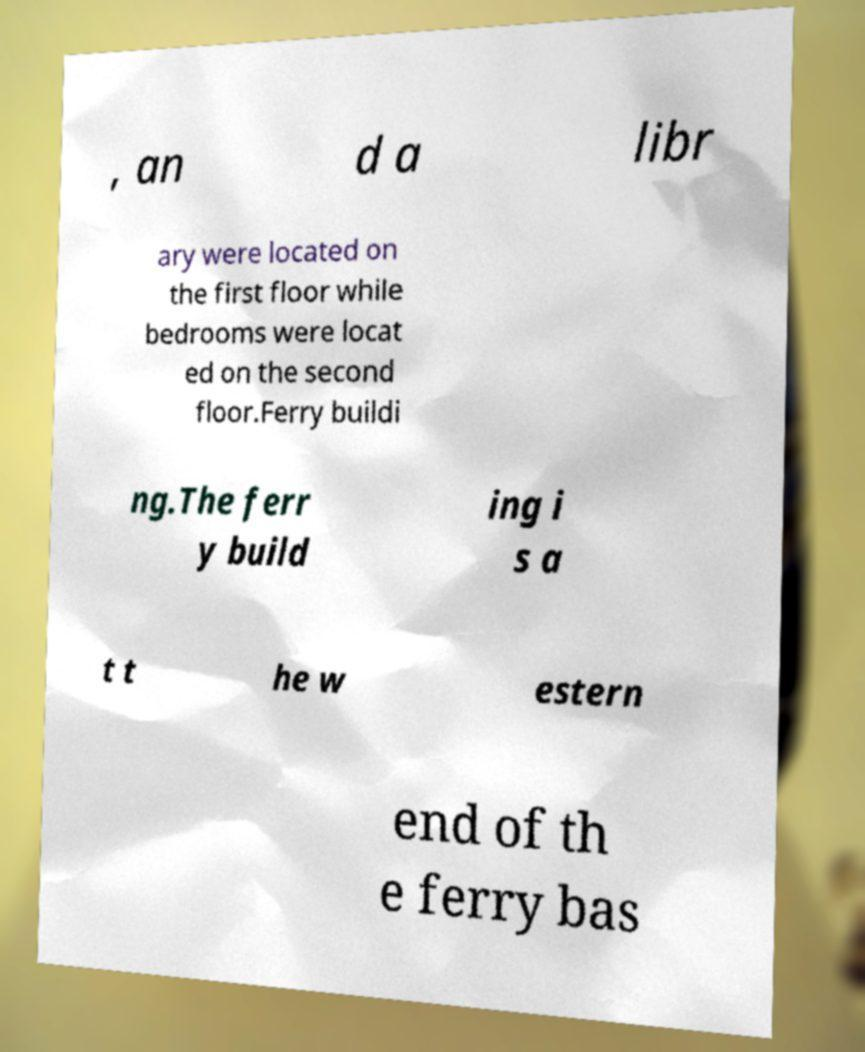There's text embedded in this image that I need extracted. Can you transcribe it verbatim? , an d a libr ary were located on the first floor while bedrooms were locat ed on the second floor.Ferry buildi ng.The ferr y build ing i s a t t he w estern end of th e ferry bas 